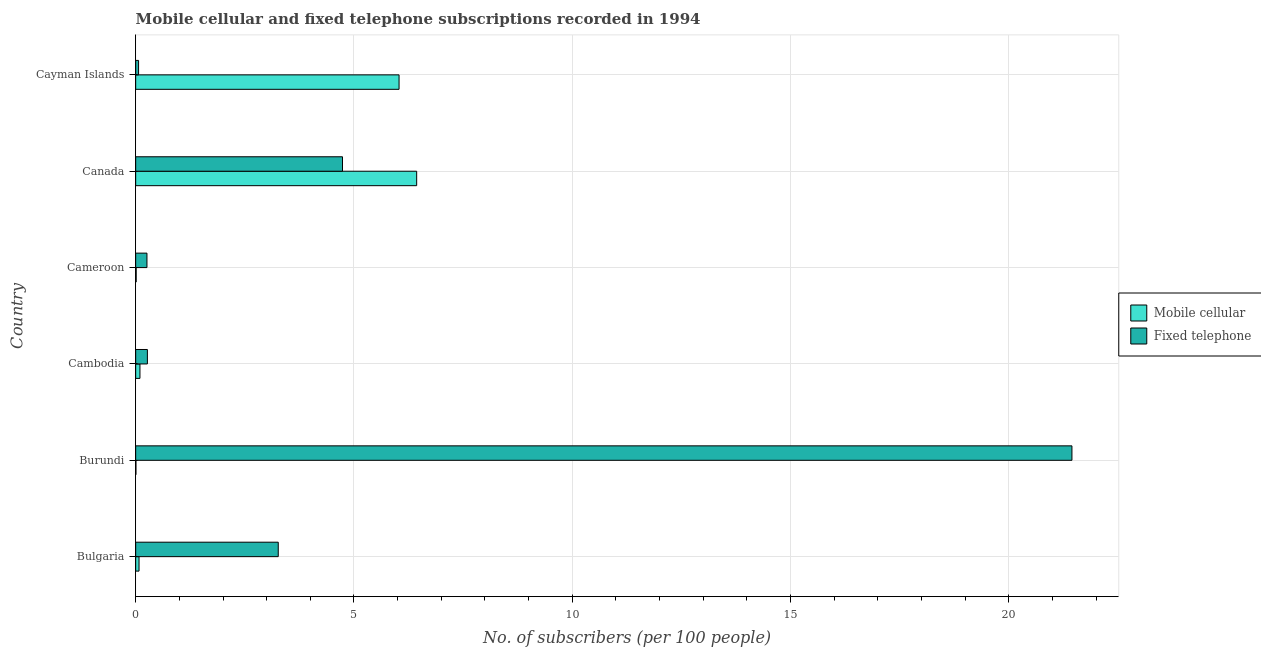Are the number of bars on each tick of the Y-axis equal?
Your response must be concise. Yes. How many bars are there on the 2nd tick from the top?
Provide a succinct answer. 2. What is the label of the 5th group of bars from the top?
Your answer should be compact. Burundi. In how many cases, is the number of bars for a given country not equal to the number of legend labels?
Provide a short and direct response. 0. What is the number of mobile cellular subscribers in Cayman Islands?
Keep it short and to the point. 6.03. Across all countries, what is the maximum number of mobile cellular subscribers?
Give a very brief answer. 6.44. Across all countries, what is the minimum number of fixed telephone subscribers?
Offer a very short reply. 0.07. In which country was the number of mobile cellular subscribers minimum?
Provide a succinct answer. Burundi. What is the total number of fixed telephone subscribers in the graph?
Give a very brief answer. 30.04. What is the difference between the number of mobile cellular subscribers in Bulgaria and that in Cayman Islands?
Provide a short and direct response. -5.96. What is the difference between the number of mobile cellular subscribers in Cambodia and the number of fixed telephone subscribers in Cayman Islands?
Give a very brief answer. 0.03. What is the average number of fixed telephone subscribers per country?
Offer a terse response. 5.01. What is the difference between the number of mobile cellular subscribers and number of fixed telephone subscribers in Bulgaria?
Offer a very short reply. -3.19. What is the ratio of the number of fixed telephone subscribers in Bulgaria to that in Canada?
Provide a short and direct response. 0.69. Is the difference between the number of fixed telephone subscribers in Bulgaria and Cayman Islands greater than the difference between the number of mobile cellular subscribers in Bulgaria and Cayman Islands?
Ensure brevity in your answer.  Yes. What is the difference between the highest and the second highest number of mobile cellular subscribers?
Your answer should be compact. 0.4. What is the difference between the highest and the lowest number of fixed telephone subscribers?
Offer a terse response. 21.38. Is the sum of the number of fixed telephone subscribers in Burundi and Cayman Islands greater than the maximum number of mobile cellular subscribers across all countries?
Your answer should be compact. Yes. What does the 2nd bar from the top in Burundi represents?
Make the answer very short. Mobile cellular. What does the 1st bar from the bottom in Cameroon represents?
Offer a very short reply. Mobile cellular. How many bars are there?
Your response must be concise. 12. How many countries are there in the graph?
Provide a short and direct response. 6. What is the difference between two consecutive major ticks on the X-axis?
Offer a very short reply. 5. Where does the legend appear in the graph?
Make the answer very short. Center right. How many legend labels are there?
Keep it short and to the point. 2. What is the title of the graph?
Offer a terse response. Mobile cellular and fixed telephone subscriptions recorded in 1994. What is the label or title of the X-axis?
Keep it short and to the point. No. of subscribers (per 100 people). What is the label or title of the Y-axis?
Your answer should be very brief. Country. What is the No. of subscribers (per 100 people) in Mobile cellular in Bulgaria?
Keep it short and to the point. 0.08. What is the No. of subscribers (per 100 people) of Fixed telephone in Bulgaria?
Make the answer very short. 3.27. What is the No. of subscribers (per 100 people) of Mobile cellular in Burundi?
Your answer should be very brief. 0.01. What is the No. of subscribers (per 100 people) in Fixed telephone in Burundi?
Provide a short and direct response. 21.44. What is the No. of subscribers (per 100 people) of Mobile cellular in Cambodia?
Your answer should be very brief. 0.1. What is the No. of subscribers (per 100 people) in Fixed telephone in Cambodia?
Keep it short and to the point. 0.27. What is the No. of subscribers (per 100 people) in Mobile cellular in Cameroon?
Ensure brevity in your answer.  0.01. What is the No. of subscribers (per 100 people) of Fixed telephone in Cameroon?
Keep it short and to the point. 0.26. What is the No. of subscribers (per 100 people) of Mobile cellular in Canada?
Your answer should be compact. 6.44. What is the No. of subscribers (per 100 people) of Fixed telephone in Canada?
Your response must be concise. 4.74. What is the No. of subscribers (per 100 people) in Mobile cellular in Cayman Islands?
Provide a short and direct response. 6.03. What is the No. of subscribers (per 100 people) of Fixed telephone in Cayman Islands?
Your answer should be very brief. 0.07. Across all countries, what is the maximum No. of subscribers (per 100 people) of Mobile cellular?
Your answer should be very brief. 6.44. Across all countries, what is the maximum No. of subscribers (per 100 people) in Fixed telephone?
Offer a terse response. 21.44. Across all countries, what is the minimum No. of subscribers (per 100 people) of Mobile cellular?
Your answer should be very brief. 0.01. Across all countries, what is the minimum No. of subscribers (per 100 people) of Fixed telephone?
Provide a succinct answer. 0.07. What is the total No. of subscribers (per 100 people) in Mobile cellular in the graph?
Ensure brevity in your answer.  12.66. What is the total No. of subscribers (per 100 people) of Fixed telephone in the graph?
Your answer should be very brief. 30.04. What is the difference between the No. of subscribers (per 100 people) in Mobile cellular in Bulgaria and that in Burundi?
Your answer should be compact. 0.07. What is the difference between the No. of subscribers (per 100 people) of Fixed telephone in Bulgaria and that in Burundi?
Keep it short and to the point. -18.18. What is the difference between the No. of subscribers (per 100 people) in Mobile cellular in Bulgaria and that in Cambodia?
Make the answer very short. -0.02. What is the difference between the No. of subscribers (per 100 people) of Fixed telephone in Bulgaria and that in Cambodia?
Your answer should be very brief. 3. What is the difference between the No. of subscribers (per 100 people) of Mobile cellular in Bulgaria and that in Cameroon?
Give a very brief answer. 0.07. What is the difference between the No. of subscribers (per 100 people) in Fixed telephone in Bulgaria and that in Cameroon?
Ensure brevity in your answer.  3.01. What is the difference between the No. of subscribers (per 100 people) in Mobile cellular in Bulgaria and that in Canada?
Offer a terse response. -6.36. What is the difference between the No. of subscribers (per 100 people) in Fixed telephone in Bulgaria and that in Canada?
Offer a very short reply. -1.47. What is the difference between the No. of subscribers (per 100 people) in Mobile cellular in Bulgaria and that in Cayman Islands?
Offer a terse response. -5.96. What is the difference between the No. of subscribers (per 100 people) of Fixed telephone in Bulgaria and that in Cayman Islands?
Make the answer very short. 3.2. What is the difference between the No. of subscribers (per 100 people) of Mobile cellular in Burundi and that in Cambodia?
Your response must be concise. -0.09. What is the difference between the No. of subscribers (per 100 people) in Fixed telephone in Burundi and that in Cambodia?
Make the answer very short. 21.17. What is the difference between the No. of subscribers (per 100 people) of Mobile cellular in Burundi and that in Cameroon?
Provide a succinct answer. -0.01. What is the difference between the No. of subscribers (per 100 people) of Fixed telephone in Burundi and that in Cameroon?
Your answer should be very brief. 21.18. What is the difference between the No. of subscribers (per 100 people) of Mobile cellular in Burundi and that in Canada?
Keep it short and to the point. -6.43. What is the difference between the No. of subscribers (per 100 people) of Fixed telephone in Burundi and that in Canada?
Offer a terse response. 16.71. What is the difference between the No. of subscribers (per 100 people) in Mobile cellular in Burundi and that in Cayman Islands?
Your answer should be very brief. -6.03. What is the difference between the No. of subscribers (per 100 people) in Fixed telephone in Burundi and that in Cayman Islands?
Your response must be concise. 21.38. What is the difference between the No. of subscribers (per 100 people) of Mobile cellular in Cambodia and that in Cameroon?
Your answer should be compact. 0.09. What is the difference between the No. of subscribers (per 100 people) of Fixed telephone in Cambodia and that in Cameroon?
Keep it short and to the point. 0.01. What is the difference between the No. of subscribers (per 100 people) of Mobile cellular in Cambodia and that in Canada?
Your answer should be compact. -6.34. What is the difference between the No. of subscribers (per 100 people) of Fixed telephone in Cambodia and that in Canada?
Your response must be concise. -4.47. What is the difference between the No. of subscribers (per 100 people) of Mobile cellular in Cambodia and that in Cayman Islands?
Make the answer very short. -5.93. What is the difference between the No. of subscribers (per 100 people) of Fixed telephone in Cambodia and that in Cayman Islands?
Provide a short and direct response. 0.2. What is the difference between the No. of subscribers (per 100 people) of Mobile cellular in Cameroon and that in Canada?
Your response must be concise. -6.42. What is the difference between the No. of subscribers (per 100 people) of Fixed telephone in Cameroon and that in Canada?
Your response must be concise. -4.48. What is the difference between the No. of subscribers (per 100 people) of Mobile cellular in Cameroon and that in Cayman Islands?
Keep it short and to the point. -6.02. What is the difference between the No. of subscribers (per 100 people) in Fixed telephone in Cameroon and that in Cayman Islands?
Your answer should be very brief. 0.19. What is the difference between the No. of subscribers (per 100 people) in Mobile cellular in Canada and that in Cayman Islands?
Offer a very short reply. 0.4. What is the difference between the No. of subscribers (per 100 people) in Fixed telephone in Canada and that in Cayman Islands?
Your answer should be compact. 4.67. What is the difference between the No. of subscribers (per 100 people) of Mobile cellular in Bulgaria and the No. of subscribers (per 100 people) of Fixed telephone in Burundi?
Keep it short and to the point. -21.37. What is the difference between the No. of subscribers (per 100 people) in Mobile cellular in Bulgaria and the No. of subscribers (per 100 people) in Fixed telephone in Cambodia?
Offer a terse response. -0.19. What is the difference between the No. of subscribers (per 100 people) in Mobile cellular in Bulgaria and the No. of subscribers (per 100 people) in Fixed telephone in Cameroon?
Your response must be concise. -0.18. What is the difference between the No. of subscribers (per 100 people) in Mobile cellular in Bulgaria and the No. of subscribers (per 100 people) in Fixed telephone in Canada?
Provide a short and direct response. -4.66. What is the difference between the No. of subscribers (per 100 people) of Mobile cellular in Bulgaria and the No. of subscribers (per 100 people) of Fixed telephone in Cayman Islands?
Offer a very short reply. 0.01. What is the difference between the No. of subscribers (per 100 people) of Mobile cellular in Burundi and the No. of subscribers (per 100 people) of Fixed telephone in Cambodia?
Make the answer very short. -0.26. What is the difference between the No. of subscribers (per 100 people) in Mobile cellular in Burundi and the No. of subscribers (per 100 people) in Fixed telephone in Cameroon?
Offer a terse response. -0.25. What is the difference between the No. of subscribers (per 100 people) of Mobile cellular in Burundi and the No. of subscribers (per 100 people) of Fixed telephone in Canada?
Your answer should be compact. -4.73. What is the difference between the No. of subscribers (per 100 people) of Mobile cellular in Burundi and the No. of subscribers (per 100 people) of Fixed telephone in Cayman Islands?
Your answer should be very brief. -0.06. What is the difference between the No. of subscribers (per 100 people) of Mobile cellular in Cambodia and the No. of subscribers (per 100 people) of Fixed telephone in Cameroon?
Provide a short and direct response. -0.16. What is the difference between the No. of subscribers (per 100 people) of Mobile cellular in Cambodia and the No. of subscribers (per 100 people) of Fixed telephone in Canada?
Your answer should be compact. -4.64. What is the difference between the No. of subscribers (per 100 people) in Mobile cellular in Cambodia and the No. of subscribers (per 100 people) in Fixed telephone in Cayman Islands?
Make the answer very short. 0.03. What is the difference between the No. of subscribers (per 100 people) of Mobile cellular in Cameroon and the No. of subscribers (per 100 people) of Fixed telephone in Canada?
Provide a succinct answer. -4.72. What is the difference between the No. of subscribers (per 100 people) in Mobile cellular in Cameroon and the No. of subscribers (per 100 people) in Fixed telephone in Cayman Islands?
Your answer should be very brief. -0.05. What is the difference between the No. of subscribers (per 100 people) of Mobile cellular in Canada and the No. of subscribers (per 100 people) of Fixed telephone in Cayman Islands?
Provide a succinct answer. 6.37. What is the average No. of subscribers (per 100 people) in Mobile cellular per country?
Keep it short and to the point. 2.11. What is the average No. of subscribers (per 100 people) of Fixed telephone per country?
Offer a terse response. 5.01. What is the difference between the No. of subscribers (per 100 people) of Mobile cellular and No. of subscribers (per 100 people) of Fixed telephone in Bulgaria?
Keep it short and to the point. -3.19. What is the difference between the No. of subscribers (per 100 people) in Mobile cellular and No. of subscribers (per 100 people) in Fixed telephone in Burundi?
Make the answer very short. -21.44. What is the difference between the No. of subscribers (per 100 people) in Mobile cellular and No. of subscribers (per 100 people) in Fixed telephone in Cambodia?
Provide a succinct answer. -0.17. What is the difference between the No. of subscribers (per 100 people) in Mobile cellular and No. of subscribers (per 100 people) in Fixed telephone in Cameroon?
Provide a succinct answer. -0.25. What is the difference between the No. of subscribers (per 100 people) in Mobile cellular and No. of subscribers (per 100 people) in Fixed telephone in Canada?
Keep it short and to the point. 1.7. What is the difference between the No. of subscribers (per 100 people) in Mobile cellular and No. of subscribers (per 100 people) in Fixed telephone in Cayman Islands?
Your answer should be very brief. 5.97. What is the ratio of the No. of subscribers (per 100 people) in Mobile cellular in Bulgaria to that in Burundi?
Offer a terse response. 12.44. What is the ratio of the No. of subscribers (per 100 people) of Fixed telephone in Bulgaria to that in Burundi?
Make the answer very short. 0.15. What is the ratio of the No. of subscribers (per 100 people) of Mobile cellular in Bulgaria to that in Cambodia?
Ensure brevity in your answer.  0.78. What is the ratio of the No. of subscribers (per 100 people) in Fixed telephone in Bulgaria to that in Cambodia?
Offer a very short reply. 12.18. What is the ratio of the No. of subscribers (per 100 people) in Mobile cellular in Bulgaria to that in Cameroon?
Keep it short and to the point. 6.51. What is the ratio of the No. of subscribers (per 100 people) in Fixed telephone in Bulgaria to that in Cameroon?
Ensure brevity in your answer.  12.64. What is the ratio of the No. of subscribers (per 100 people) of Mobile cellular in Bulgaria to that in Canada?
Your answer should be compact. 0.01. What is the ratio of the No. of subscribers (per 100 people) of Fixed telephone in Bulgaria to that in Canada?
Your answer should be very brief. 0.69. What is the ratio of the No. of subscribers (per 100 people) of Mobile cellular in Bulgaria to that in Cayman Islands?
Give a very brief answer. 0.01. What is the ratio of the No. of subscribers (per 100 people) of Fixed telephone in Bulgaria to that in Cayman Islands?
Ensure brevity in your answer.  49.06. What is the ratio of the No. of subscribers (per 100 people) of Mobile cellular in Burundi to that in Cambodia?
Keep it short and to the point. 0.06. What is the ratio of the No. of subscribers (per 100 people) in Fixed telephone in Burundi to that in Cambodia?
Offer a terse response. 79.95. What is the ratio of the No. of subscribers (per 100 people) in Mobile cellular in Burundi to that in Cameroon?
Offer a very short reply. 0.52. What is the ratio of the No. of subscribers (per 100 people) in Fixed telephone in Burundi to that in Cameroon?
Make the answer very short. 83.02. What is the ratio of the No. of subscribers (per 100 people) of Mobile cellular in Burundi to that in Canada?
Offer a very short reply. 0. What is the ratio of the No. of subscribers (per 100 people) in Fixed telephone in Burundi to that in Canada?
Keep it short and to the point. 4.53. What is the ratio of the No. of subscribers (per 100 people) of Mobile cellular in Burundi to that in Cayman Islands?
Make the answer very short. 0. What is the ratio of the No. of subscribers (per 100 people) in Fixed telephone in Burundi to that in Cayman Islands?
Ensure brevity in your answer.  322.13. What is the ratio of the No. of subscribers (per 100 people) in Mobile cellular in Cambodia to that in Cameroon?
Provide a short and direct response. 8.31. What is the ratio of the No. of subscribers (per 100 people) of Fixed telephone in Cambodia to that in Cameroon?
Provide a succinct answer. 1.04. What is the ratio of the No. of subscribers (per 100 people) in Mobile cellular in Cambodia to that in Canada?
Your answer should be very brief. 0.02. What is the ratio of the No. of subscribers (per 100 people) of Fixed telephone in Cambodia to that in Canada?
Your answer should be compact. 0.06. What is the ratio of the No. of subscribers (per 100 people) of Mobile cellular in Cambodia to that in Cayman Islands?
Your response must be concise. 0.02. What is the ratio of the No. of subscribers (per 100 people) in Fixed telephone in Cambodia to that in Cayman Islands?
Offer a terse response. 4.03. What is the ratio of the No. of subscribers (per 100 people) in Mobile cellular in Cameroon to that in Canada?
Provide a short and direct response. 0. What is the ratio of the No. of subscribers (per 100 people) in Fixed telephone in Cameroon to that in Canada?
Your response must be concise. 0.05. What is the ratio of the No. of subscribers (per 100 people) of Mobile cellular in Cameroon to that in Cayman Islands?
Provide a succinct answer. 0. What is the ratio of the No. of subscribers (per 100 people) in Fixed telephone in Cameroon to that in Cayman Islands?
Ensure brevity in your answer.  3.88. What is the ratio of the No. of subscribers (per 100 people) in Mobile cellular in Canada to that in Cayman Islands?
Provide a succinct answer. 1.07. What is the ratio of the No. of subscribers (per 100 people) of Fixed telephone in Canada to that in Cayman Islands?
Make the answer very short. 71.16. What is the difference between the highest and the second highest No. of subscribers (per 100 people) in Mobile cellular?
Keep it short and to the point. 0.4. What is the difference between the highest and the second highest No. of subscribers (per 100 people) in Fixed telephone?
Make the answer very short. 16.71. What is the difference between the highest and the lowest No. of subscribers (per 100 people) of Mobile cellular?
Give a very brief answer. 6.43. What is the difference between the highest and the lowest No. of subscribers (per 100 people) in Fixed telephone?
Keep it short and to the point. 21.38. 